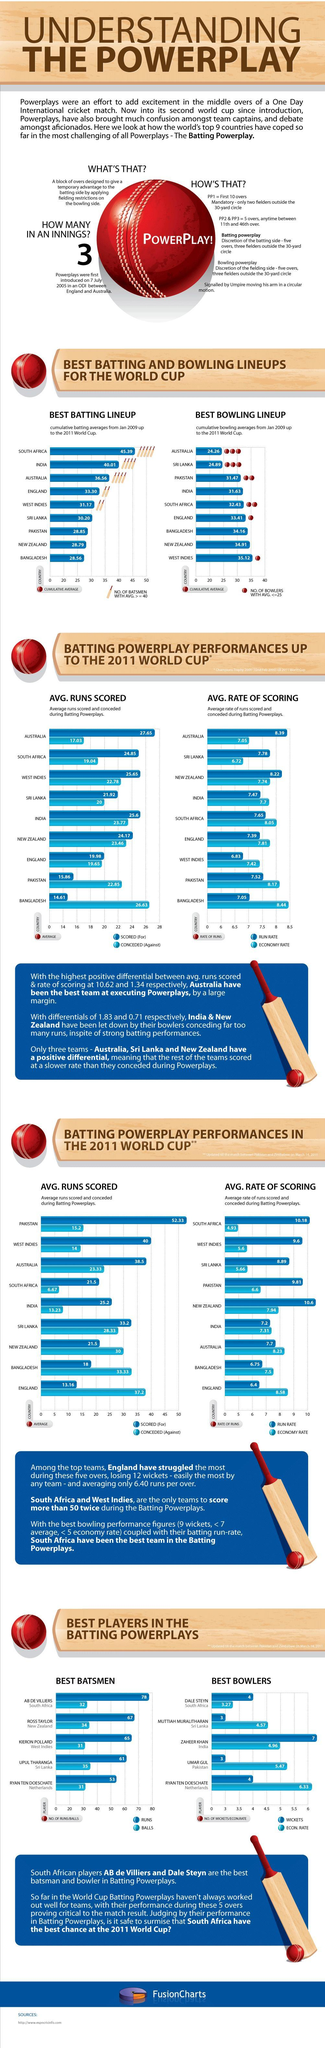Which country has the second-highest batting lineups?
Answer the question with a short phrase. India Which country has the second-lowest batting lineups? New Zealand Which country has the second-lowest bowling lineups? New Zealand Which country has the second-highest bowling lineups? Srilanka 